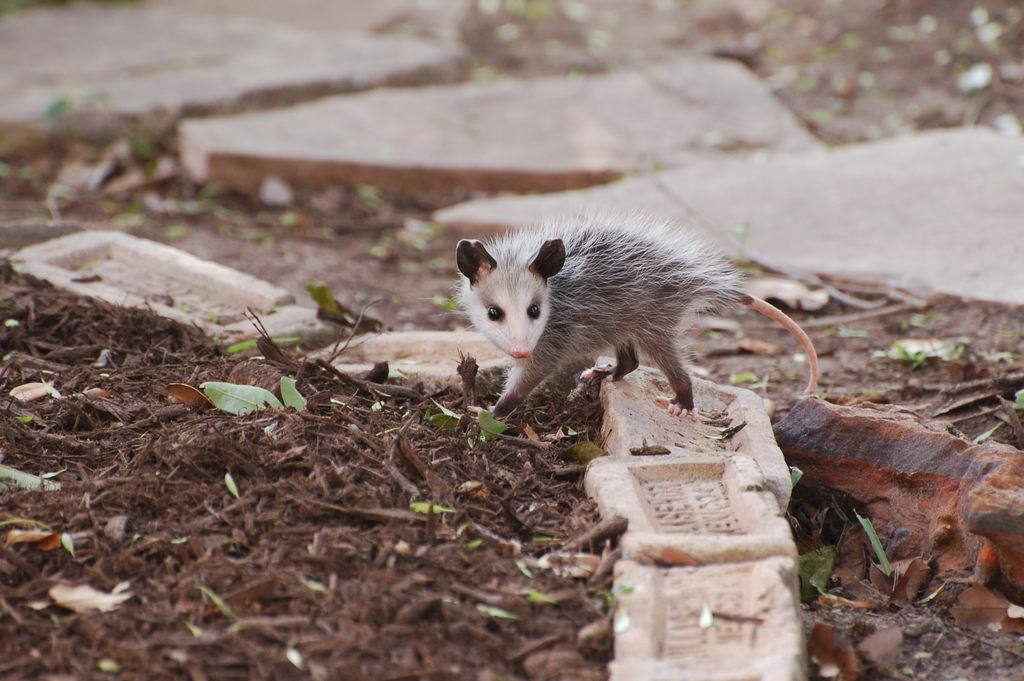What type of animal is on the ground in the image? There is a small rat on the ground in the image. What else can be seen on the ground in the image? There are leaves on the ground in the image. What type of cake is being served by the zebra in the image? There is no cake or zebra present in the image; it features a small rat and leaves on the ground. 